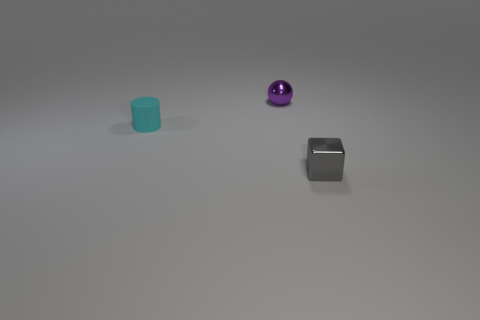Add 1 small gray metal things. How many objects exist? 4 Subtract all spheres. How many objects are left? 2 Add 2 gray metallic cubes. How many gray metallic cubes exist? 3 Subtract 1 purple spheres. How many objects are left? 2 Subtract 1 blocks. How many blocks are left? 0 Subtract all green balls. Subtract all purple cubes. How many balls are left? 1 Subtract all green blocks. How many brown spheres are left? 0 Subtract all large red blocks. Subtract all spheres. How many objects are left? 2 Add 1 tiny gray objects. How many tiny gray objects are left? 2 